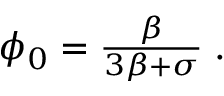Convert formula to latex. <formula><loc_0><loc_0><loc_500><loc_500>\begin{array} { r } { \phi _ { 0 } = \frac { \beta } { 3 \beta + \sigma } \, . } \end{array}</formula> 